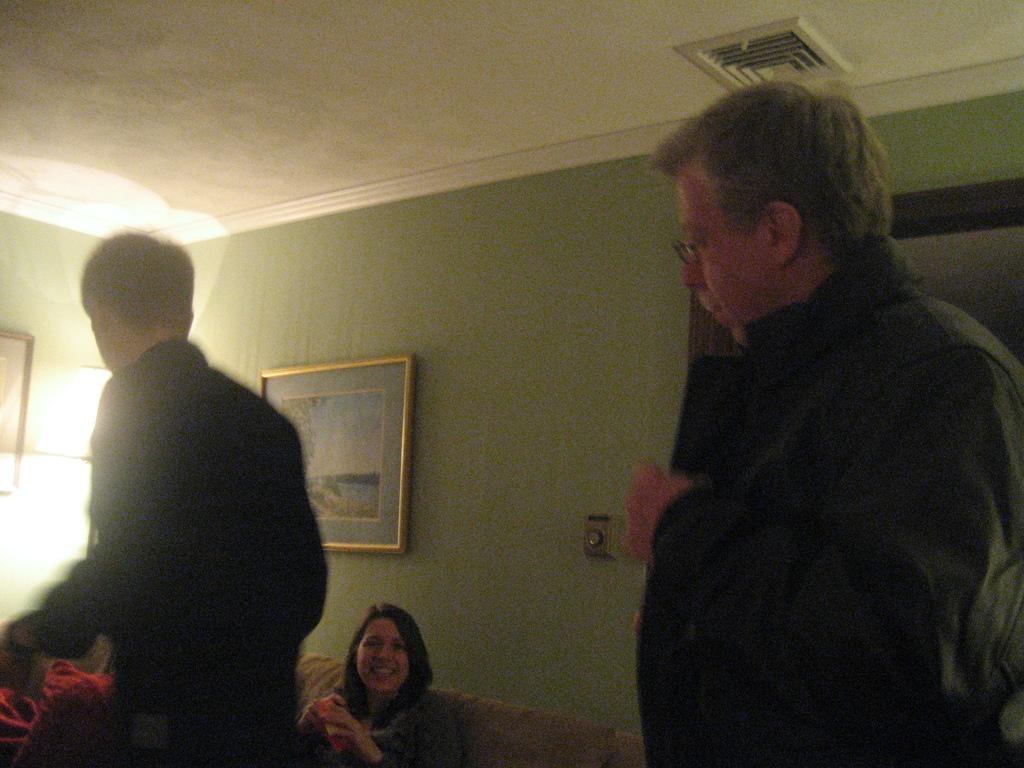In one or two sentences, can you explain what this image depicts? In this picture we can observe three members. Two of them were men and the other was a woman sitting in the sofa. She is smiling. We can observe a photo frame fixed to the green color wall. On the left side we can observe a lamp. 